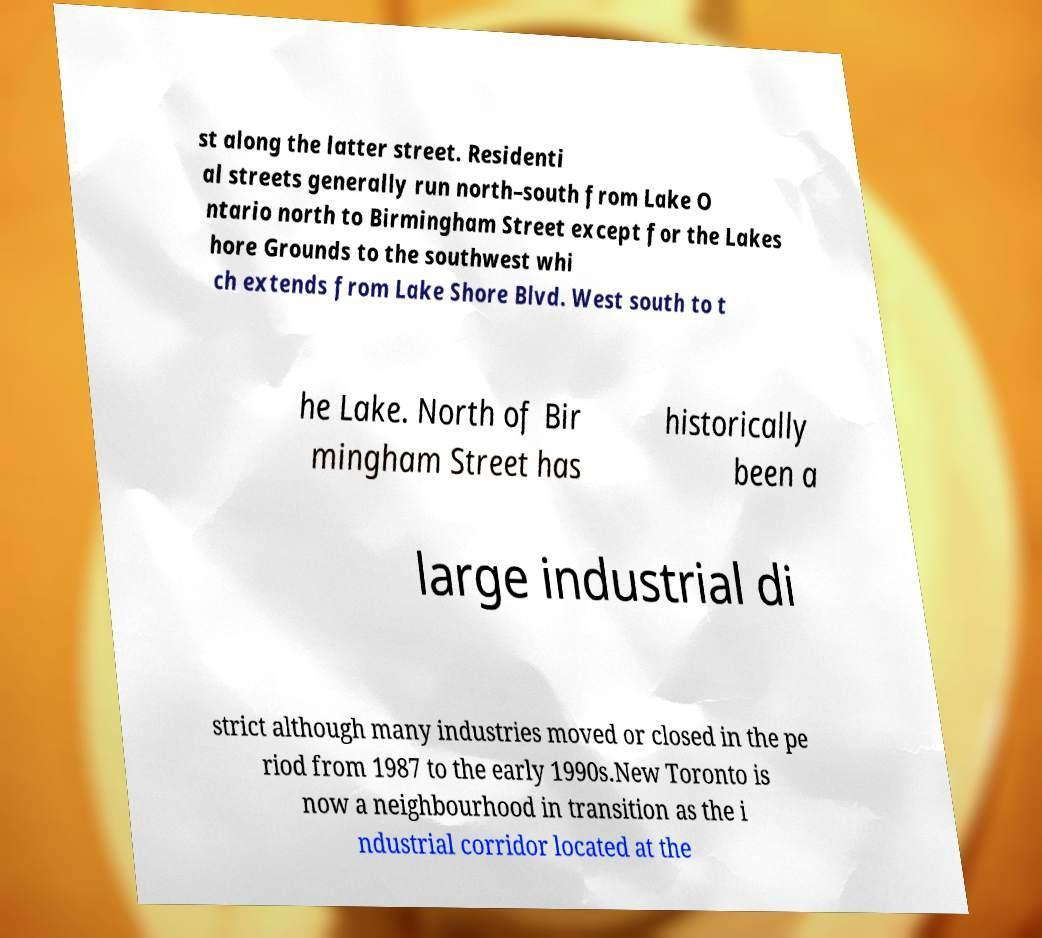Please read and relay the text visible in this image. What does it say? st along the latter street. Residenti al streets generally run north–south from Lake O ntario north to Birmingham Street except for the Lakes hore Grounds to the southwest whi ch extends from Lake Shore Blvd. West south to t he Lake. North of Bir mingham Street has historically been a large industrial di strict although many industries moved or closed in the pe riod from 1987 to the early 1990s.New Toronto is now a neighbourhood in transition as the i ndustrial corridor located at the 